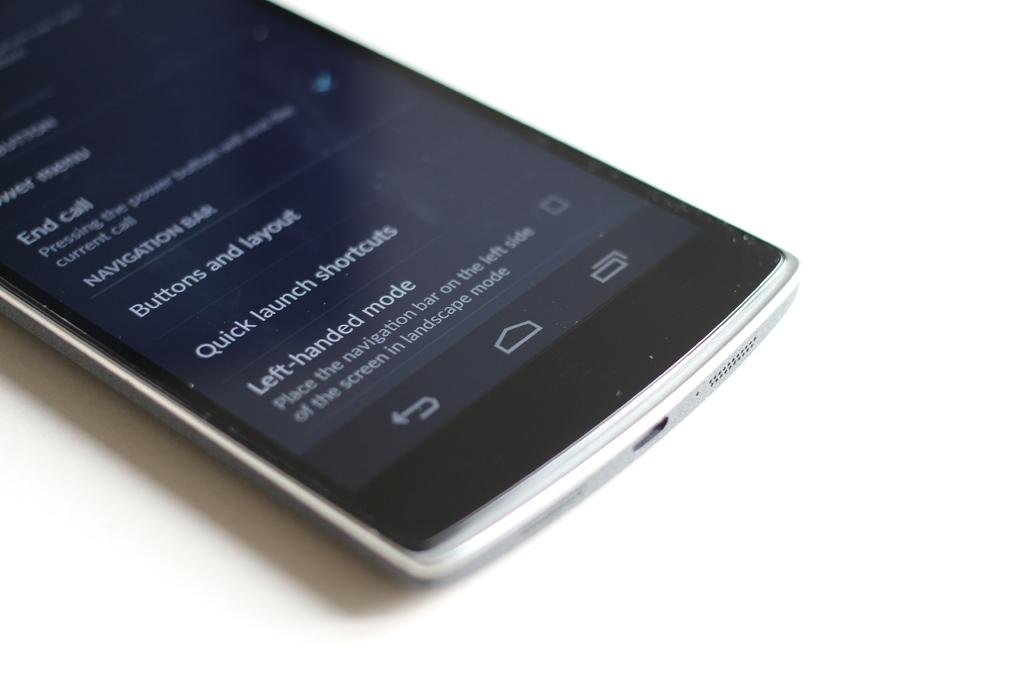<image>
Create a compact narrative representing the image presented. A cell phone with the words quick launch shortcuts and left handed mode on the bottom of the screen. 